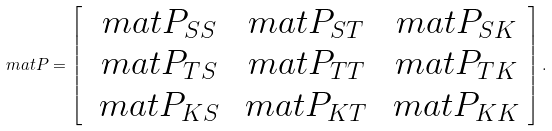<formula> <loc_0><loc_0><loc_500><loc_500>\ m a t { P } = \left [ \begin{array} { c c c } \ m a t { P } _ { S S } & \ m a t { P } _ { S T } & \ m a t { P } _ { S K } \\ \ m a t { P } _ { T S } & \ m a t { P } _ { T T } & \ m a t { P } _ { T K } \\ \ m a t { P } _ { K S } & \ m a t { P } _ { K T } & \ m a t { P } _ { K K } \end{array} \right ] .</formula> 